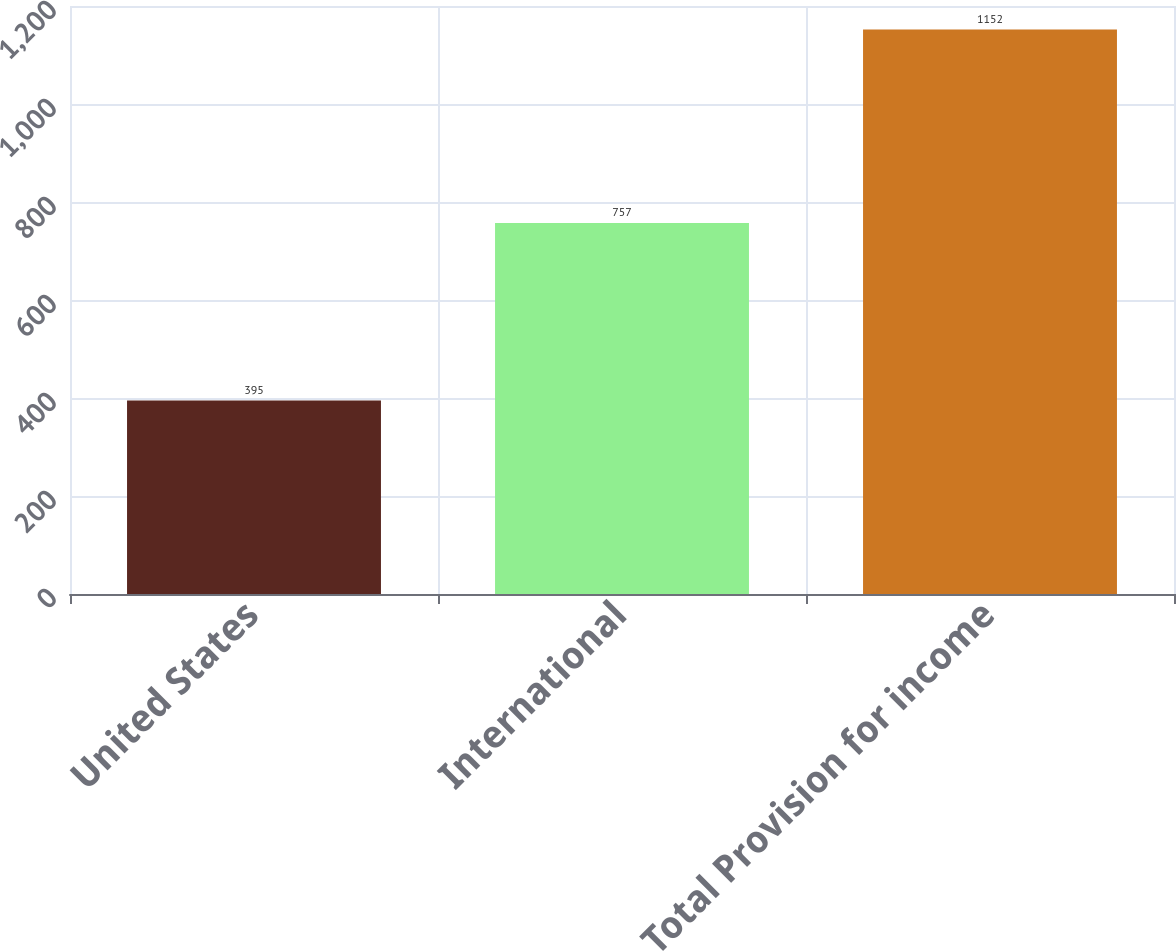Convert chart to OTSL. <chart><loc_0><loc_0><loc_500><loc_500><bar_chart><fcel>United States<fcel>International<fcel>Total Provision for income<nl><fcel>395<fcel>757<fcel>1152<nl></chart> 